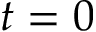<formula> <loc_0><loc_0><loc_500><loc_500>t = 0</formula> 